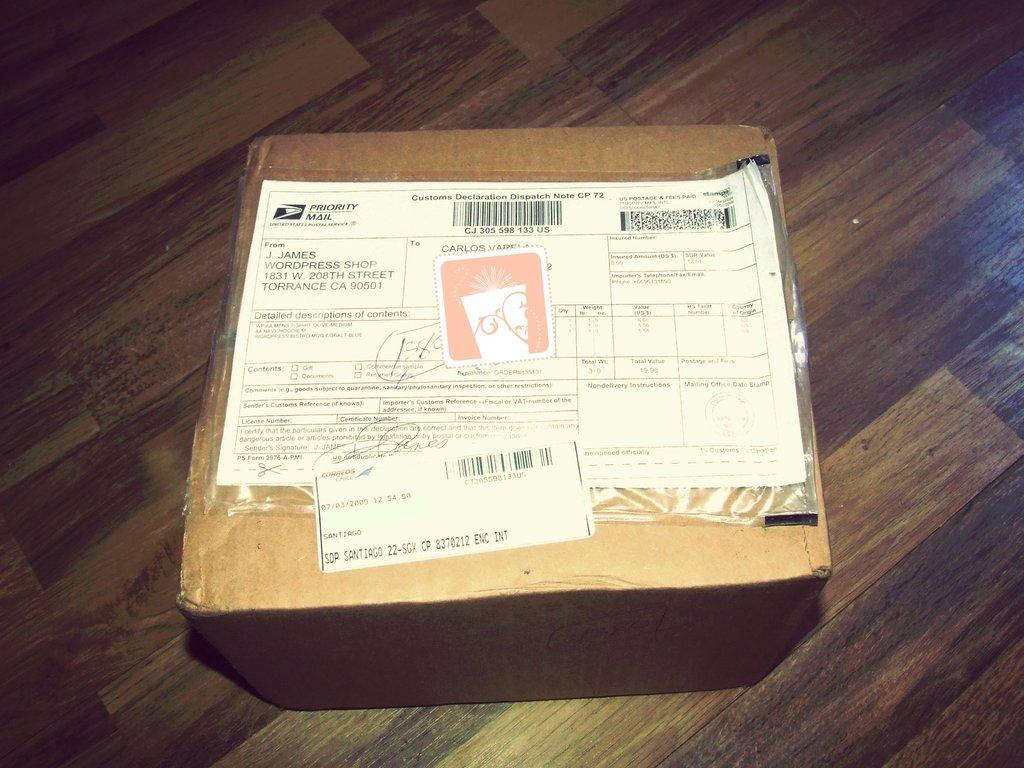<image>
Present a compact description of the photo's key features. a paper with Priority Mail written on it 